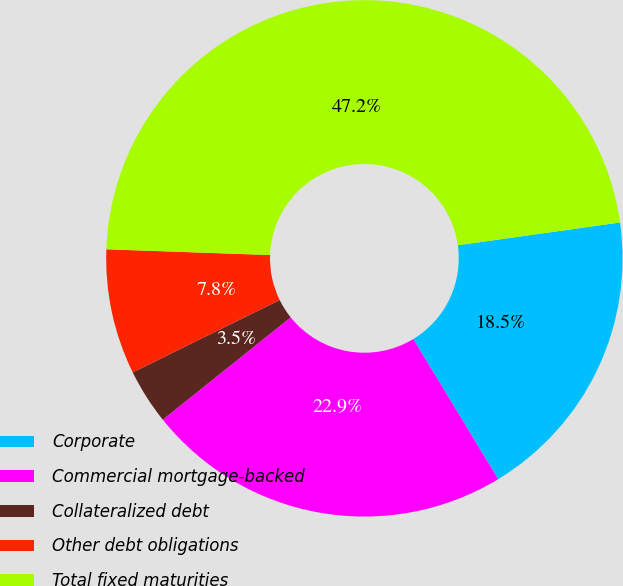Convert chart to OTSL. <chart><loc_0><loc_0><loc_500><loc_500><pie_chart><fcel>Corporate<fcel>Commercial mortgage-backed<fcel>Collateralized debt<fcel>Other debt obligations<fcel>Total fixed maturities<nl><fcel>18.55%<fcel>22.93%<fcel>3.46%<fcel>7.84%<fcel>47.22%<nl></chart> 